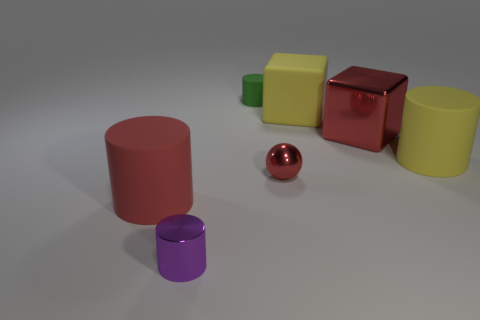Subtract all yellow matte cylinders. How many cylinders are left? 3 Add 3 small red shiny things. How many objects exist? 10 Subtract all purple cylinders. How many cylinders are left? 3 Subtract all red cylinders. Subtract all blue spheres. How many cylinders are left? 3 Subtract all cylinders. How many objects are left? 3 Add 6 small cyan matte balls. How many small cyan matte balls exist? 6 Subtract 0 brown cylinders. How many objects are left? 7 Subtract all big shiny objects. Subtract all yellow rubber blocks. How many objects are left? 5 Add 3 tiny purple things. How many tiny purple things are left? 4 